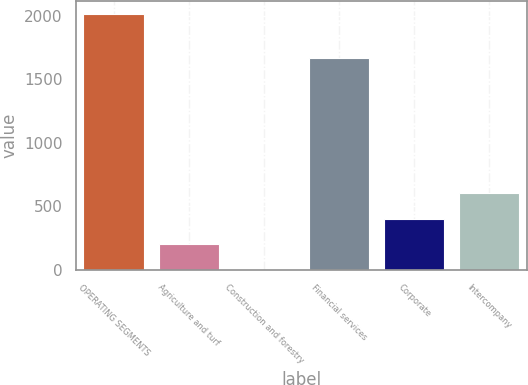Convert chart to OTSL. <chart><loc_0><loc_0><loc_500><loc_500><bar_chart><fcel>OPERATING SEGMENTS<fcel>Agriculture and turf<fcel>Construction and forestry<fcel>Financial services<fcel>Corporate<fcel>Intercompany<nl><fcel>2013<fcel>203.1<fcel>2<fcel>1668<fcel>404.2<fcel>605.3<nl></chart> 